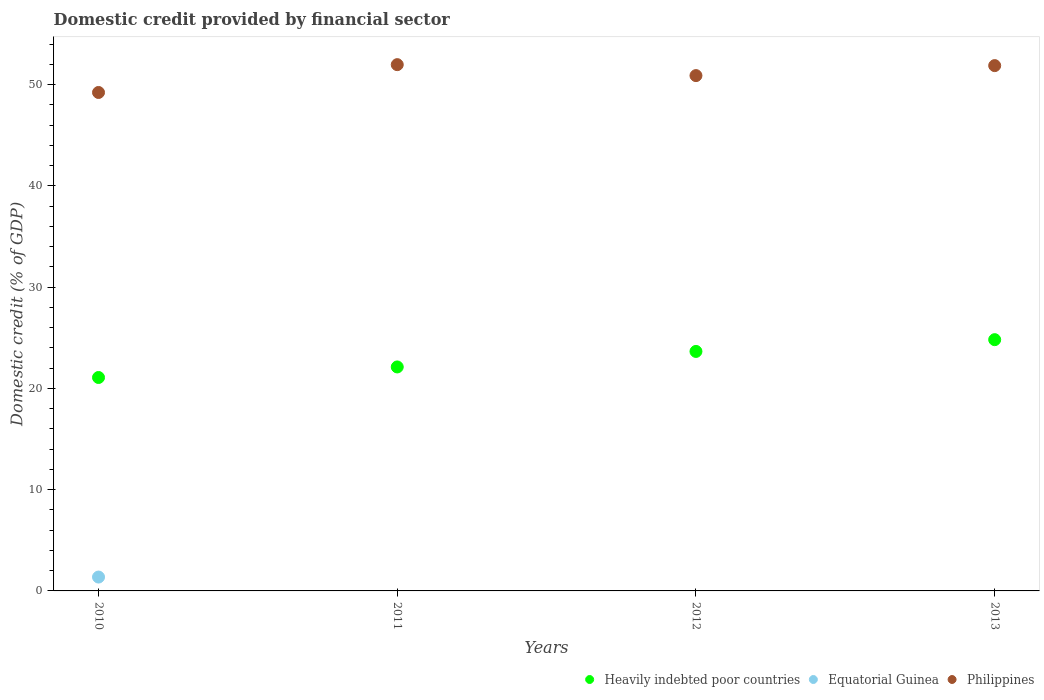What is the domestic credit in Equatorial Guinea in 2012?
Your answer should be compact. 0. Across all years, what is the maximum domestic credit in Heavily indebted poor countries?
Provide a short and direct response. 24.82. Across all years, what is the minimum domestic credit in Philippines?
Your response must be concise. 49.23. In which year was the domestic credit in Philippines maximum?
Provide a short and direct response. 2011. What is the total domestic credit in Equatorial Guinea in the graph?
Your response must be concise. 1.37. What is the difference between the domestic credit in Philippines in 2010 and that in 2011?
Ensure brevity in your answer.  -2.75. What is the difference between the domestic credit in Equatorial Guinea in 2010 and the domestic credit in Heavily indebted poor countries in 2012?
Keep it short and to the point. -22.29. What is the average domestic credit in Philippines per year?
Ensure brevity in your answer.  51. In the year 2012, what is the difference between the domestic credit in Heavily indebted poor countries and domestic credit in Philippines?
Offer a terse response. -27.24. What is the ratio of the domestic credit in Philippines in 2011 to that in 2012?
Give a very brief answer. 1.02. What is the difference between the highest and the second highest domestic credit in Philippines?
Provide a short and direct response. 0.1. What is the difference between the highest and the lowest domestic credit in Heavily indebted poor countries?
Keep it short and to the point. 3.74. In how many years, is the domestic credit in Heavily indebted poor countries greater than the average domestic credit in Heavily indebted poor countries taken over all years?
Offer a terse response. 2. Is the sum of the domestic credit in Heavily indebted poor countries in 2010 and 2013 greater than the maximum domestic credit in Philippines across all years?
Provide a succinct answer. No. Is it the case that in every year, the sum of the domestic credit in Philippines and domestic credit in Heavily indebted poor countries  is greater than the domestic credit in Equatorial Guinea?
Provide a succinct answer. Yes. Does the domestic credit in Philippines monotonically increase over the years?
Give a very brief answer. No. Is the domestic credit in Philippines strictly greater than the domestic credit in Equatorial Guinea over the years?
Make the answer very short. Yes. Does the graph contain grids?
Provide a succinct answer. No. Where does the legend appear in the graph?
Ensure brevity in your answer.  Bottom right. How are the legend labels stacked?
Keep it short and to the point. Horizontal. What is the title of the graph?
Offer a terse response. Domestic credit provided by financial sector. Does "Venezuela" appear as one of the legend labels in the graph?
Offer a very short reply. No. What is the label or title of the X-axis?
Offer a very short reply. Years. What is the label or title of the Y-axis?
Provide a short and direct response. Domestic credit (% of GDP). What is the Domestic credit (% of GDP) of Heavily indebted poor countries in 2010?
Give a very brief answer. 21.08. What is the Domestic credit (% of GDP) in Equatorial Guinea in 2010?
Ensure brevity in your answer.  1.37. What is the Domestic credit (% of GDP) in Philippines in 2010?
Your answer should be compact. 49.23. What is the Domestic credit (% of GDP) in Heavily indebted poor countries in 2011?
Keep it short and to the point. 22.12. What is the Domestic credit (% of GDP) of Equatorial Guinea in 2011?
Provide a succinct answer. 0. What is the Domestic credit (% of GDP) of Philippines in 2011?
Offer a terse response. 51.98. What is the Domestic credit (% of GDP) of Heavily indebted poor countries in 2012?
Your response must be concise. 23.66. What is the Domestic credit (% of GDP) of Philippines in 2012?
Provide a short and direct response. 50.9. What is the Domestic credit (% of GDP) of Heavily indebted poor countries in 2013?
Your answer should be compact. 24.82. What is the Domestic credit (% of GDP) of Equatorial Guinea in 2013?
Your answer should be very brief. 0. What is the Domestic credit (% of GDP) in Philippines in 2013?
Offer a terse response. 51.88. Across all years, what is the maximum Domestic credit (% of GDP) of Heavily indebted poor countries?
Your answer should be compact. 24.82. Across all years, what is the maximum Domestic credit (% of GDP) in Equatorial Guinea?
Provide a succinct answer. 1.37. Across all years, what is the maximum Domestic credit (% of GDP) in Philippines?
Your answer should be compact. 51.98. Across all years, what is the minimum Domestic credit (% of GDP) in Heavily indebted poor countries?
Provide a succinct answer. 21.08. Across all years, what is the minimum Domestic credit (% of GDP) in Equatorial Guinea?
Provide a succinct answer. 0. Across all years, what is the minimum Domestic credit (% of GDP) of Philippines?
Provide a succinct answer. 49.23. What is the total Domestic credit (% of GDP) of Heavily indebted poor countries in the graph?
Offer a very short reply. 91.67. What is the total Domestic credit (% of GDP) in Equatorial Guinea in the graph?
Provide a succinct answer. 1.37. What is the total Domestic credit (% of GDP) in Philippines in the graph?
Ensure brevity in your answer.  204. What is the difference between the Domestic credit (% of GDP) in Heavily indebted poor countries in 2010 and that in 2011?
Your answer should be compact. -1.04. What is the difference between the Domestic credit (% of GDP) of Philippines in 2010 and that in 2011?
Offer a very short reply. -2.75. What is the difference between the Domestic credit (% of GDP) in Heavily indebted poor countries in 2010 and that in 2012?
Make the answer very short. -2.57. What is the difference between the Domestic credit (% of GDP) of Philippines in 2010 and that in 2012?
Your response must be concise. -1.67. What is the difference between the Domestic credit (% of GDP) of Heavily indebted poor countries in 2010 and that in 2013?
Offer a terse response. -3.74. What is the difference between the Domestic credit (% of GDP) of Philippines in 2010 and that in 2013?
Make the answer very short. -2.65. What is the difference between the Domestic credit (% of GDP) in Heavily indebted poor countries in 2011 and that in 2012?
Your answer should be very brief. -1.53. What is the difference between the Domestic credit (% of GDP) of Philippines in 2011 and that in 2012?
Offer a terse response. 1.08. What is the difference between the Domestic credit (% of GDP) of Heavily indebted poor countries in 2011 and that in 2013?
Offer a terse response. -2.69. What is the difference between the Domestic credit (% of GDP) in Philippines in 2011 and that in 2013?
Your answer should be very brief. 0.1. What is the difference between the Domestic credit (% of GDP) of Heavily indebted poor countries in 2012 and that in 2013?
Keep it short and to the point. -1.16. What is the difference between the Domestic credit (% of GDP) of Philippines in 2012 and that in 2013?
Your answer should be compact. -0.99. What is the difference between the Domestic credit (% of GDP) of Heavily indebted poor countries in 2010 and the Domestic credit (% of GDP) of Philippines in 2011?
Make the answer very short. -30.9. What is the difference between the Domestic credit (% of GDP) of Equatorial Guinea in 2010 and the Domestic credit (% of GDP) of Philippines in 2011?
Keep it short and to the point. -50.61. What is the difference between the Domestic credit (% of GDP) in Heavily indebted poor countries in 2010 and the Domestic credit (% of GDP) in Philippines in 2012?
Give a very brief answer. -29.82. What is the difference between the Domestic credit (% of GDP) of Equatorial Guinea in 2010 and the Domestic credit (% of GDP) of Philippines in 2012?
Give a very brief answer. -49.53. What is the difference between the Domestic credit (% of GDP) of Heavily indebted poor countries in 2010 and the Domestic credit (% of GDP) of Philippines in 2013?
Your answer should be compact. -30.8. What is the difference between the Domestic credit (% of GDP) of Equatorial Guinea in 2010 and the Domestic credit (% of GDP) of Philippines in 2013?
Offer a terse response. -50.52. What is the difference between the Domestic credit (% of GDP) of Heavily indebted poor countries in 2011 and the Domestic credit (% of GDP) of Philippines in 2012?
Offer a very short reply. -28.78. What is the difference between the Domestic credit (% of GDP) of Heavily indebted poor countries in 2011 and the Domestic credit (% of GDP) of Philippines in 2013?
Your answer should be compact. -29.76. What is the difference between the Domestic credit (% of GDP) of Heavily indebted poor countries in 2012 and the Domestic credit (% of GDP) of Philippines in 2013?
Offer a very short reply. -28.23. What is the average Domestic credit (% of GDP) of Heavily indebted poor countries per year?
Offer a very short reply. 22.92. What is the average Domestic credit (% of GDP) in Equatorial Guinea per year?
Make the answer very short. 0.34. What is the average Domestic credit (% of GDP) of Philippines per year?
Ensure brevity in your answer.  51. In the year 2010, what is the difference between the Domestic credit (% of GDP) of Heavily indebted poor countries and Domestic credit (% of GDP) of Equatorial Guinea?
Offer a terse response. 19.71. In the year 2010, what is the difference between the Domestic credit (% of GDP) of Heavily indebted poor countries and Domestic credit (% of GDP) of Philippines?
Offer a very short reply. -28.15. In the year 2010, what is the difference between the Domestic credit (% of GDP) of Equatorial Guinea and Domestic credit (% of GDP) of Philippines?
Provide a succinct answer. -47.86. In the year 2011, what is the difference between the Domestic credit (% of GDP) in Heavily indebted poor countries and Domestic credit (% of GDP) in Philippines?
Provide a short and direct response. -29.86. In the year 2012, what is the difference between the Domestic credit (% of GDP) of Heavily indebted poor countries and Domestic credit (% of GDP) of Philippines?
Your answer should be very brief. -27.24. In the year 2013, what is the difference between the Domestic credit (% of GDP) in Heavily indebted poor countries and Domestic credit (% of GDP) in Philippines?
Give a very brief answer. -27.07. What is the ratio of the Domestic credit (% of GDP) of Heavily indebted poor countries in 2010 to that in 2011?
Offer a terse response. 0.95. What is the ratio of the Domestic credit (% of GDP) of Philippines in 2010 to that in 2011?
Your answer should be very brief. 0.95. What is the ratio of the Domestic credit (% of GDP) in Heavily indebted poor countries in 2010 to that in 2012?
Your answer should be compact. 0.89. What is the ratio of the Domestic credit (% of GDP) in Philippines in 2010 to that in 2012?
Keep it short and to the point. 0.97. What is the ratio of the Domestic credit (% of GDP) in Heavily indebted poor countries in 2010 to that in 2013?
Offer a very short reply. 0.85. What is the ratio of the Domestic credit (% of GDP) in Philippines in 2010 to that in 2013?
Give a very brief answer. 0.95. What is the ratio of the Domestic credit (% of GDP) in Heavily indebted poor countries in 2011 to that in 2012?
Provide a short and direct response. 0.94. What is the ratio of the Domestic credit (% of GDP) of Philippines in 2011 to that in 2012?
Your response must be concise. 1.02. What is the ratio of the Domestic credit (% of GDP) of Heavily indebted poor countries in 2011 to that in 2013?
Make the answer very short. 0.89. What is the ratio of the Domestic credit (% of GDP) of Heavily indebted poor countries in 2012 to that in 2013?
Ensure brevity in your answer.  0.95. What is the ratio of the Domestic credit (% of GDP) in Philippines in 2012 to that in 2013?
Keep it short and to the point. 0.98. What is the difference between the highest and the second highest Domestic credit (% of GDP) of Heavily indebted poor countries?
Make the answer very short. 1.16. What is the difference between the highest and the second highest Domestic credit (% of GDP) in Philippines?
Your answer should be very brief. 0.1. What is the difference between the highest and the lowest Domestic credit (% of GDP) in Heavily indebted poor countries?
Your response must be concise. 3.74. What is the difference between the highest and the lowest Domestic credit (% of GDP) of Equatorial Guinea?
Offer a very short reply. 1.37. What is the difference between the highest and the lowest Domestic credit (% of GDP) of Philippines?
Your answer should be very brief. 2.75. 